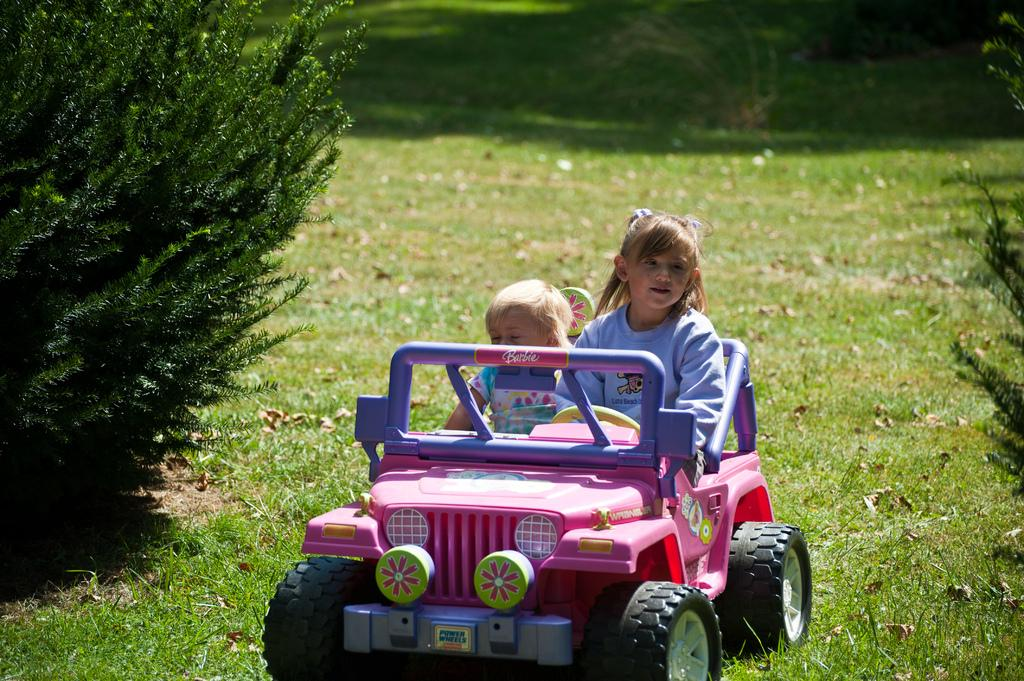Who is present in the image? There are kids in the image. What are the kids doing in the image? The kids are in a pink jeep. What can be seen on the left side of the image? There is a plant on the left side of the image. What type of ground is visible in the image? There is grass on the ground in the image. What type of income can be seen in the image? There is no reference to income in the image; it features kids in a pink jeep, a plant, and grassy ground. How many cats are visible in the image? There are no cats present in the image. 